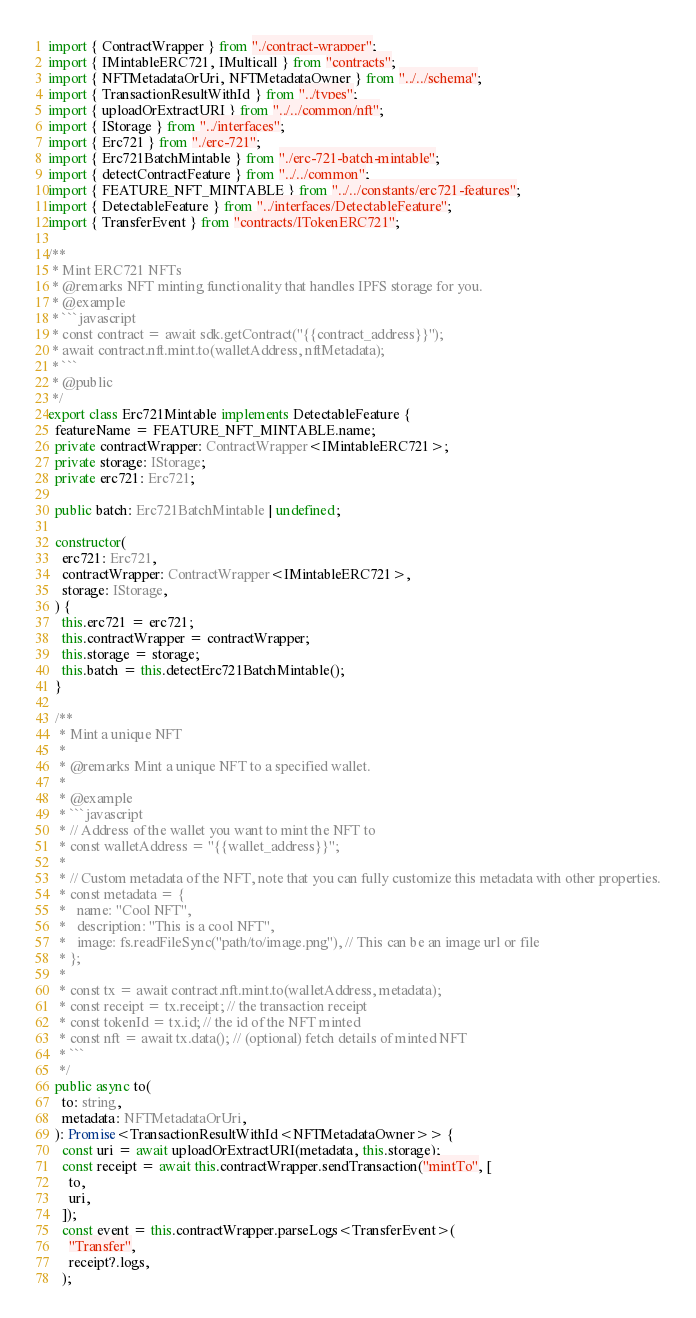<code> <loc_0><loc_0><loc_500><loc_500><_TypeScript_>import { ContractWrapper } from "./contract-wrapper";
import { IMintableERC721, IMulticall } from "contracts";
import { NFTMetadataOrUri, NFTMetadataOwner } from "../../schema";
import { TransactionResultWithId } from "../types";
import { uploadOrExtractURI } from "../../common/nft";
import { IStorage } from "../interfaces";
import { Erc721 } from "./erc-721";
import { Erc721BatchMintable } from "./erc-721-batch-mintable";
import { detectContractFeature } from "../../common";
import { FEATURE_NFT_MINTABLE } from "../../constants/erc721-features";
import { DetectableFeature } from "../interfaces/DetectableFeature";
import { TransferEvent } from "contracts/ITokenERC721";

/**
 * Mint ERC721 NFTs
 * @remarks NFT minting functionality that handles IPFS storage for you.
 * @example
 * ```javascript
 * const contract = await sdk.getContract("{{contract_address}}");
 * await contract.nft.mint.to(walletAddress, nftMetadata);
 * ```
 * @public
 */
export class Erc721Mintable implements DetectableFeature {
  featureName = FEATURE_NFT_MINTABLE.name;
  private contractWrapper: ContractWrapper<IMintableERC721>;
  private storage: IStorage;
  private erc721: Erc721;

  public batch: Erc721BatchMintable | undefined;

  constructor(
    erc721: Erc721,
    contractWrapper: ContractWrapper<IMintableERC721>,
    storage: IStorage,
  ) {
    this.erc721 = erc721;
    this.contractWrapper = contractWrapper;
    this.storage = storage;
    this.batch = this.detectErc721BatchMintable();
  }

  /**
   * Mint a unique NFT
   *
   * @remarks Mint a unique NFT to a specified wallet.
   *
   * @example
   * ```javascript
   * // Address of the wallet you want to mint the NFT to
   * const walletAddress = "{{wallet_address}}";
   *
   * // Custom metadata of the NFT, note that you can fully customize this metadata with other properties.
   * const metadata = {
   *   name: "Cool NFT",
   *   description: "This is a cool NFT",
   *   image: fs.readFileSync("path/to/image.png"), // This can be an image url or file
   * };
   *
   * const tx = await contract.nft.mint.to(walletAddress, metadata);
   * const receipt = tx.receipt; // the transaction receipt
   * const tokenId = tx.id; // the id of the NFT minted
   * const nft = await tx.data(); // (optional) fetch details of minted NFT
   * ```
   */
  public async to(
    to: string,
    metadata: NFTMetadataOrUri,
  ): Promise<TransactionResultWithId<NFTMetadataOwner>> {
    const uri = await uploadOrExtractURI(metadata, this.storage);
    const receipt = await this.contractWrapper.sendTransaction("mintTo", [
      to,
      uri,
    ]);
    const event = this.contractWrapper.parseLogs<TransferEvent>(
      "Transfer",
      receipt?.logs,
    );</code> 